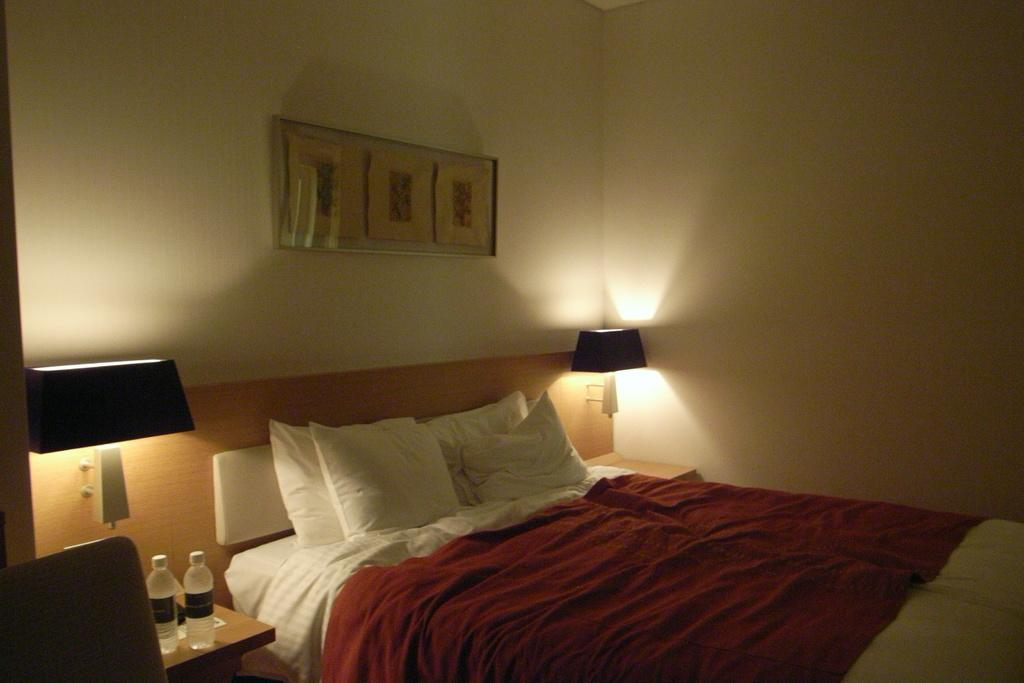What type of space is shown in the image? The image is an inside view of a room. What furniture is present in the room? There is a bed and a table in the room. What lighting fixtures are in the room? There are lamps in the room. What items can be seen on the table? There are bottles on the table. What is on the bed? The bed has pillows and a bed sheet. What decorative item is attached to the wall? There is a frame attached to the wall. Can you hear the guitar being played in the room in the image? There is no guitar present in the image, so it cannot be heard being played. 